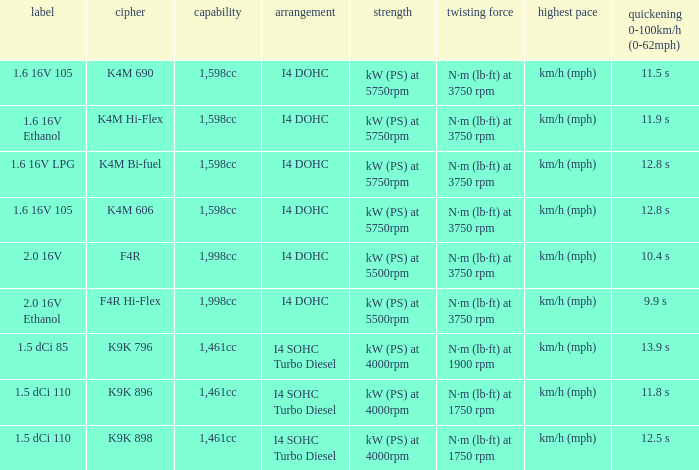What is the code of 1.5 dci 110, which has a capacity of 1,461cc? K9K 896, K9K 898. 